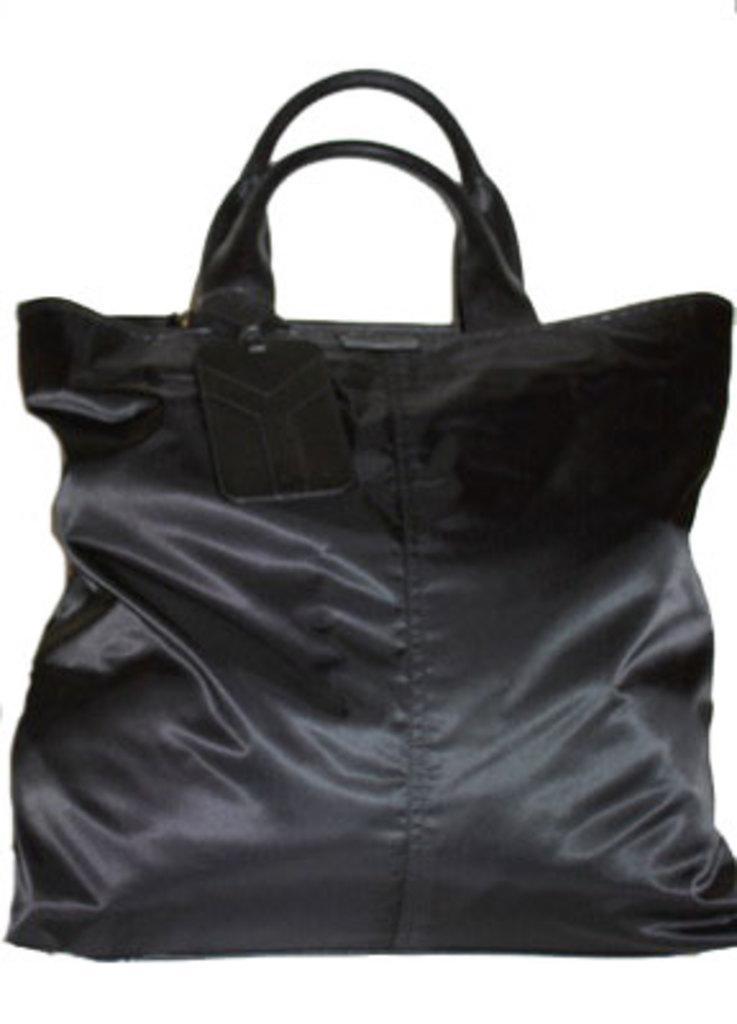Can you describe this image briefly? In this picture there is a bag made of leather and holder is given to it 